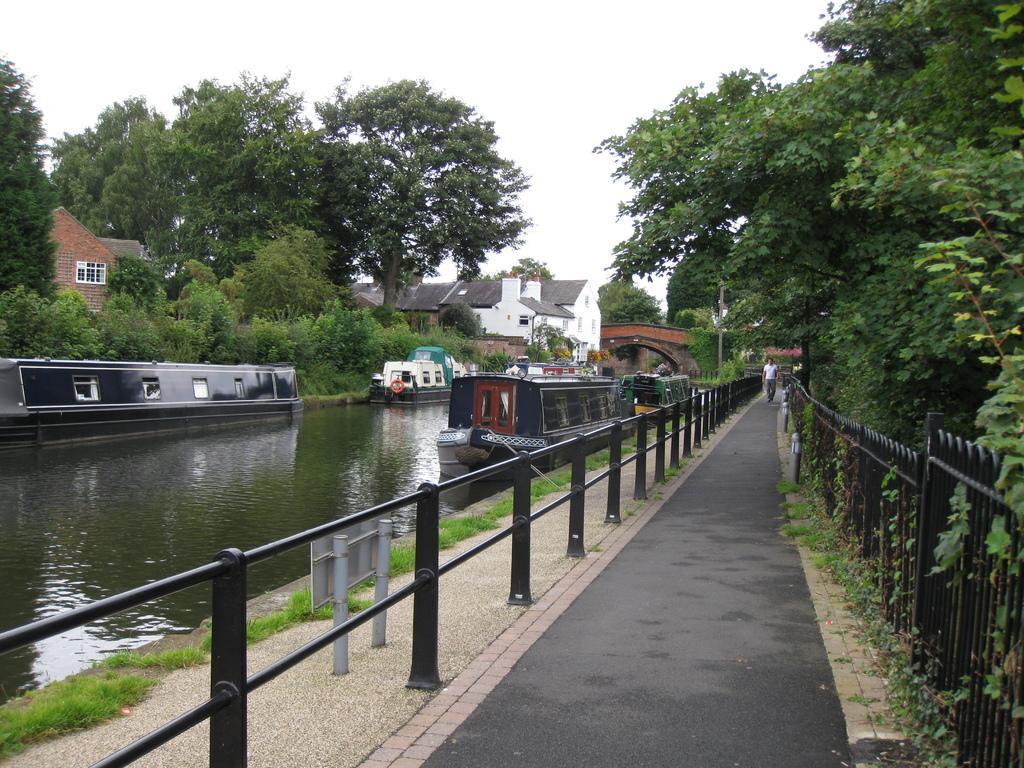Describe this image in one or two sentences. In this picture we can see boats on water, here we can see an object, fences, poles and a person on the road, here we can see a bridge, buildings, trees and we can see sky in the background. 